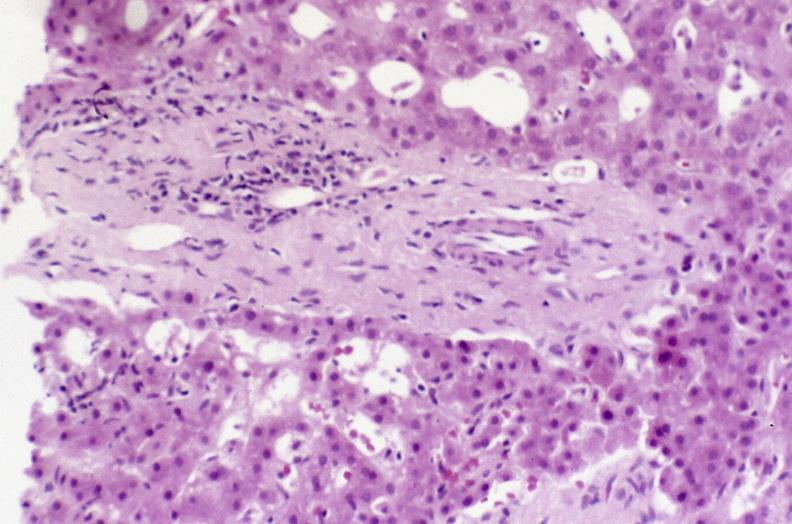does this image show recovery of ducts?
Answer the question using a single word or phrase. Yes 